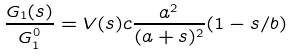<formula> <loc_0><loc_0><loc_500><loc_500>\frac { G _ { 1 } ( s ) } { G _ { 1 } ^ { 0 } } = V ( s ) c \frac { a ^ { 2 } } { ( a + s ) ^ { 2 } } ( 1 - s / b )</formula> 